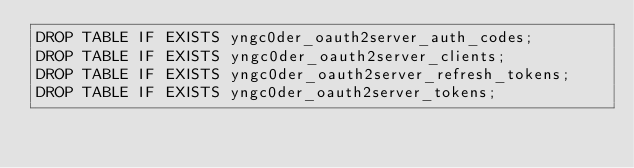Convert code to text. <code><loc_0><loc_0><loc_500><loc_500><_SQL_>DROP TABLE IF EXISTS yngc0der_oauth2server_auth_codes;
DROP TABLE IF EXISTS yngc0der_oauth2server_clients;
DROP TABLE IF EXISTS yngc0der_oauth2server_refresh_tokens;
DROP TABLE IF EXISTS yngc0der_oauth2server_tokens;
</code> 